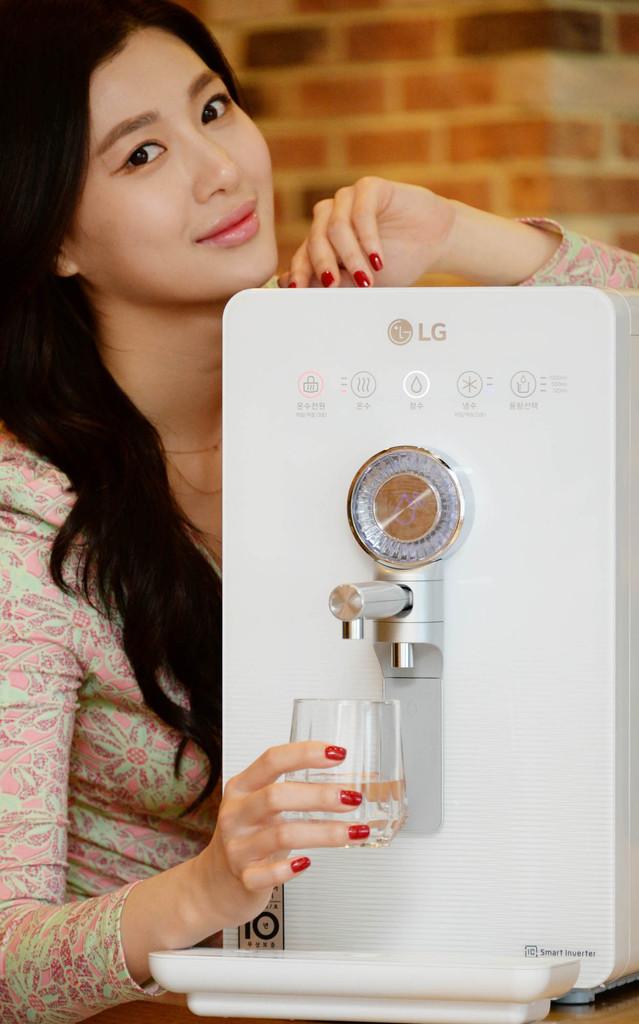What company makes this juicer?
Your answer should be very brief. Lg. 